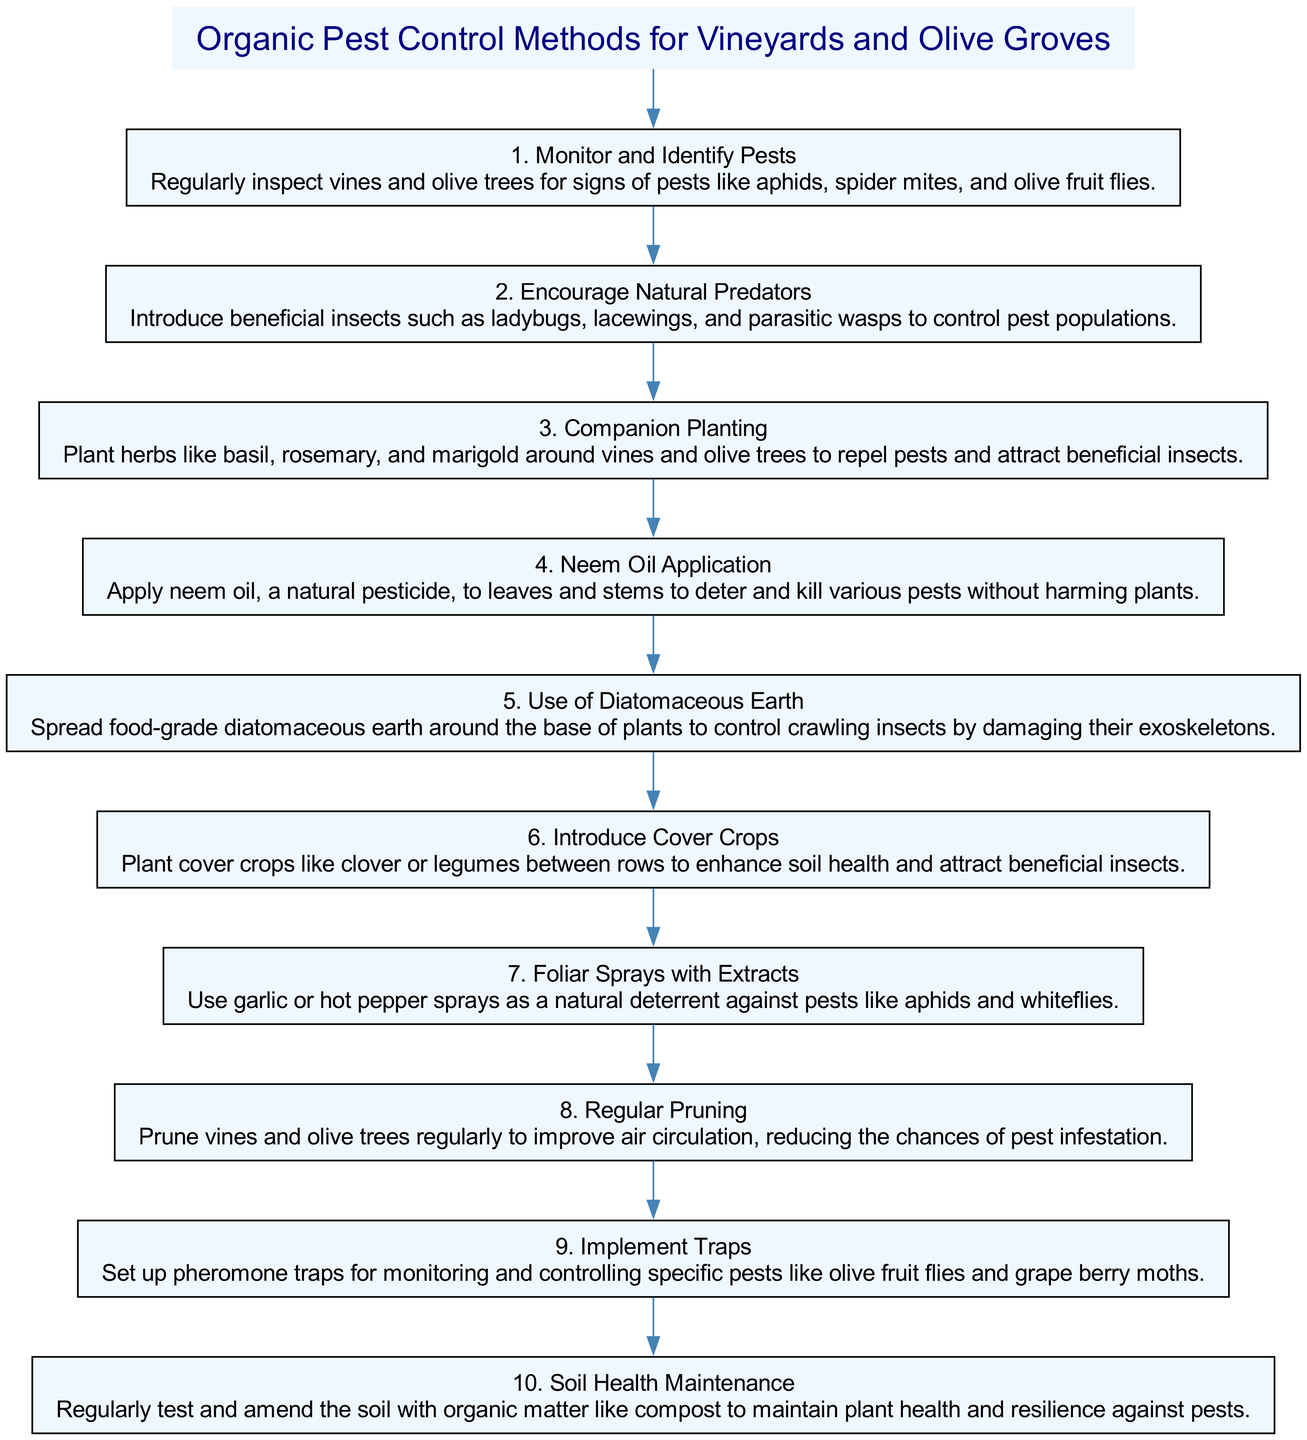What is the first step in the organic pest control methods? The diagram starts with the first node labeled "1. Monitor and Identify Pests," which indicates that this is the first action to be taken.
Answer: Monitor and Identify Pests How many steps are outlined in the diagram? By counting the nodes representing the steps, we find there are a total of 10 distinct steps listed in the flow chart.
Answer: 10 Which pest management method involves beneficial insects? In reviewing the nodes, the second step is "2. Encourage Natural Predators," which directly refers to introducing beneficial insects for pest control.
Answer: Encourage Natural Predators What is the relationship between "Neem Oil Application" and "Regular Pruning"? Looking at the flow, "Neem Oil Application" is the fourth step, and "Regular Pruning" is the eighth step. There are several steps in between, indicating that each method is a separate action in the sequence of organic pest control without a direct connection.
Answer: No direct relationship What can you use to control crawling insects according to the diagram? The fifth step specifically states "Use of Diatomaceous Earth," which is mentioned as a method to control crawling insects by damaging their exoskeletons.
Answer: Diatomaceous Earth Which two methods suggest using natural deterrents against pests? The diagram lists "Neem Oil Application" (fourth step) and "Foliar Sprays with Extracts" (seventh step) as methods that utilize natural products to deter pests. Together, they form a strategy to manage pest populations organically.
Answer: Neem Oil Application and Foliar Sprays with Extracts What should be planted between rows according to the guidelines? The sixth step mentions "Introduce Cover Crops," specifically suggesting that cover crops like clover or legumes can be beneficial when planted between rows.
Answer: Cover Crops Which step focuses on improving soil health? The tenth step is titled "Soil Health Maintenance," and it emphasizes the importance of testing and amending soil with organic matter for overall plant health.
Answer: Soil Health Maintenance What is recommended to monitor specific pests like olive fruit flies? The ninth step instructs to "Implement Traps," which specifically involves setting up pheromone traps for monitoring certain pest populations.
Answer: Implement Traps 